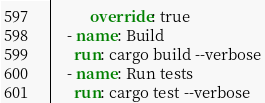Convert code to text. <code><loc_0><loc_0><loc_500><loc_500><_YAML_>          override: true
    - name: Build
      run: cargo build --verbose
    - name: Run tests
      run: cargo test --verbose
</code> 